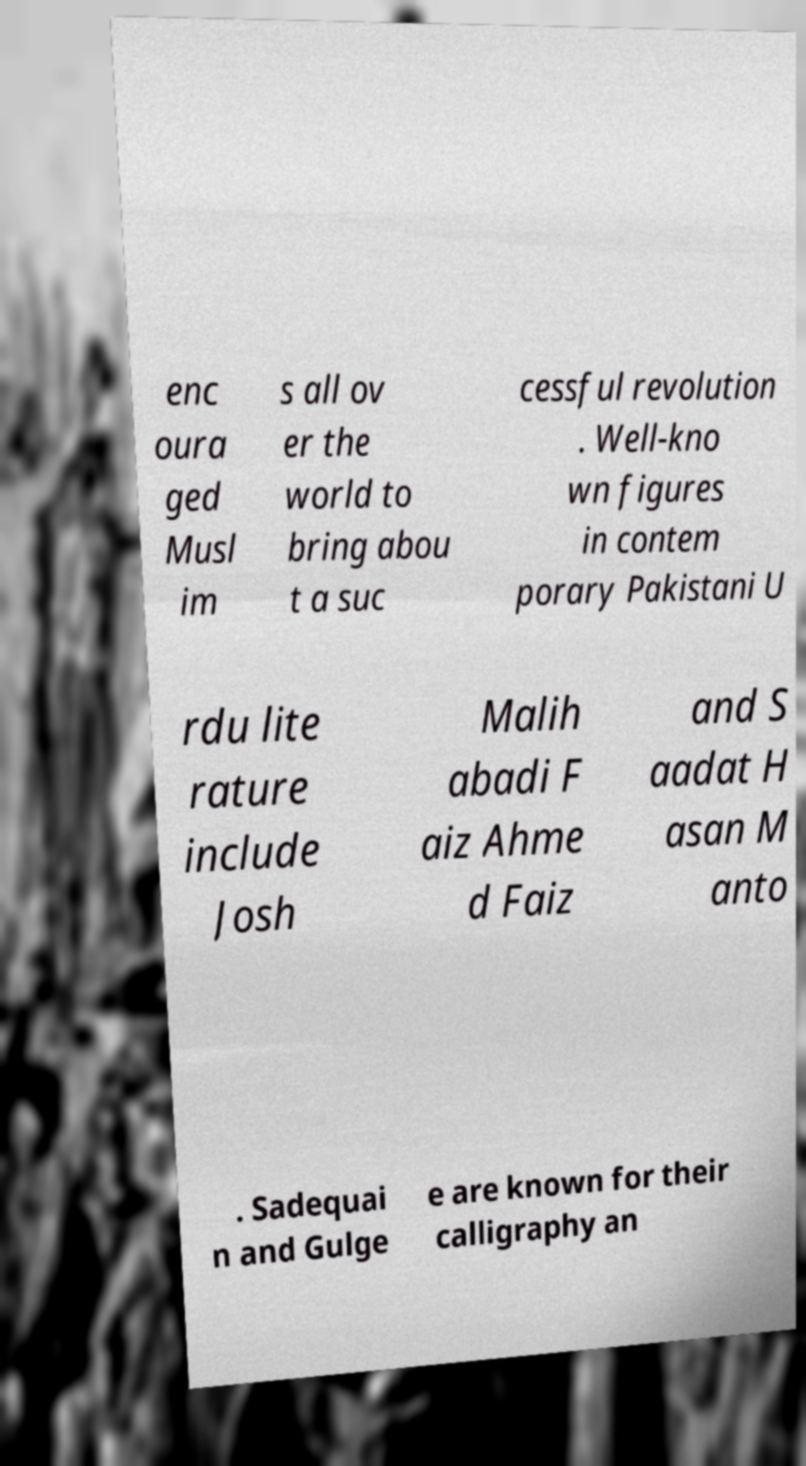For documentation purposes, I need the text within this image transcribed. Could you provide that? enc oura ged Musl im s all ov er the world to bring abou t a suc cessful revolution . Well-kno wn figures in contem porary Pakistani U rdu lite rature include Josh Malih abadi F aiz Ahme d Faiz and S aadat H asan M anto . Sadequai n and Gulge e are known for their calligraphy an 